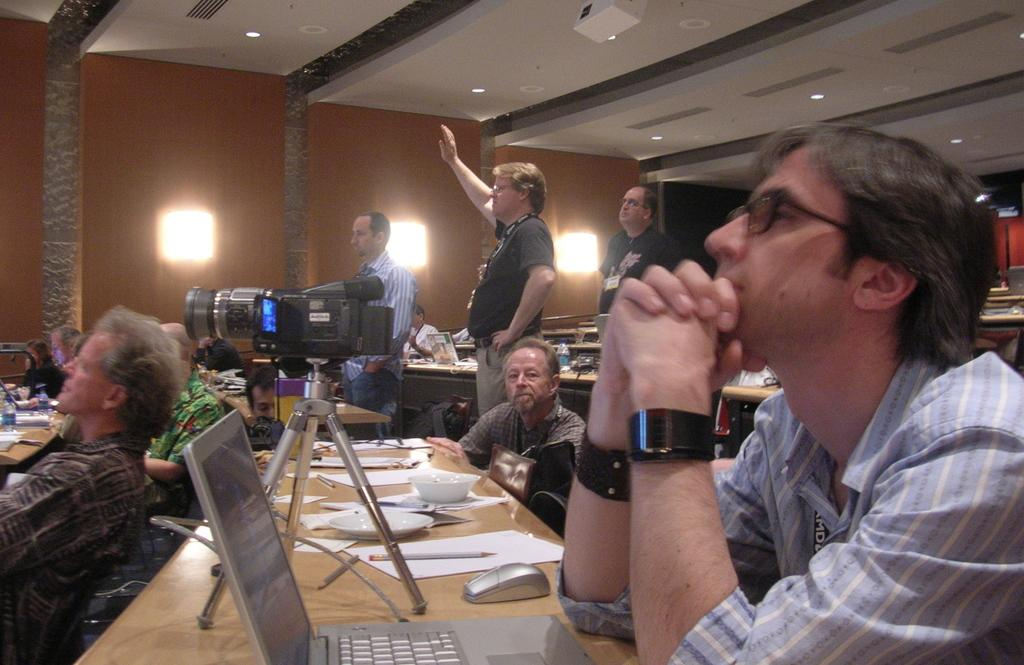How many people are in the image? There is a group of people in the image. What is on the table in the image? There is a laptop, a mouse, a paper, a pen, a plate, and a bowl on the table. What is the purpose of the mouse on the table? The mouse is likely used for controlling the laptop. What can be seen in the background of the image? There is a cupboard and a light in the background of the image. What type of pet is sitting on the table in the image? There is no pet present on the table in the image. Who is the coach of the group of people in the image? The image does not provide information about a coach or any leadership role among the group of people. 